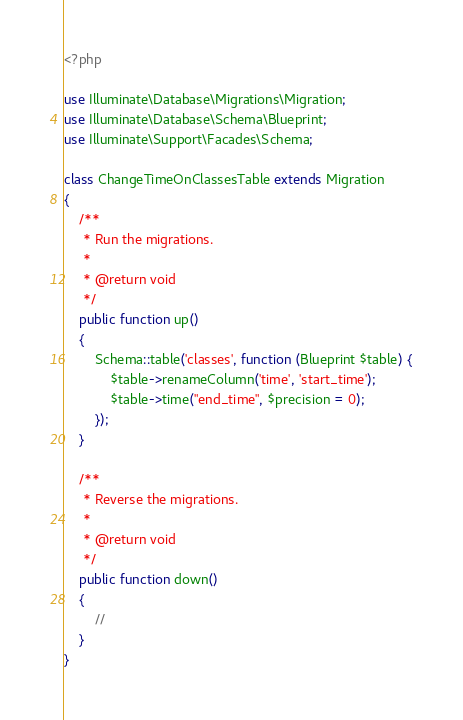Convert code to text. <code><loc_0><loc_0><loc_500><loc_500><_PHP_><?php

use Illuminate\Database\Migrations\Migration;
use Illuminate\Database\Schema\Blueprint;
use Illuminate\Support\Facades\Schema;

class ChangeTimeOnClassesTable extends Migration
{
    /**
     * Run the migrations.
     *
     * @return void
     */
    public function up()
    {
        Schema::table('classes', function (Blueprint $table) {
            $table->renameColumn('time', 'start_time');
            $table->time("end_time", $precision = 0);
        });
    }

    /**
     * Reverse the migrations.
     *
     * @return void
     */
    public function down()
    {
        //
    }
}
</code> 